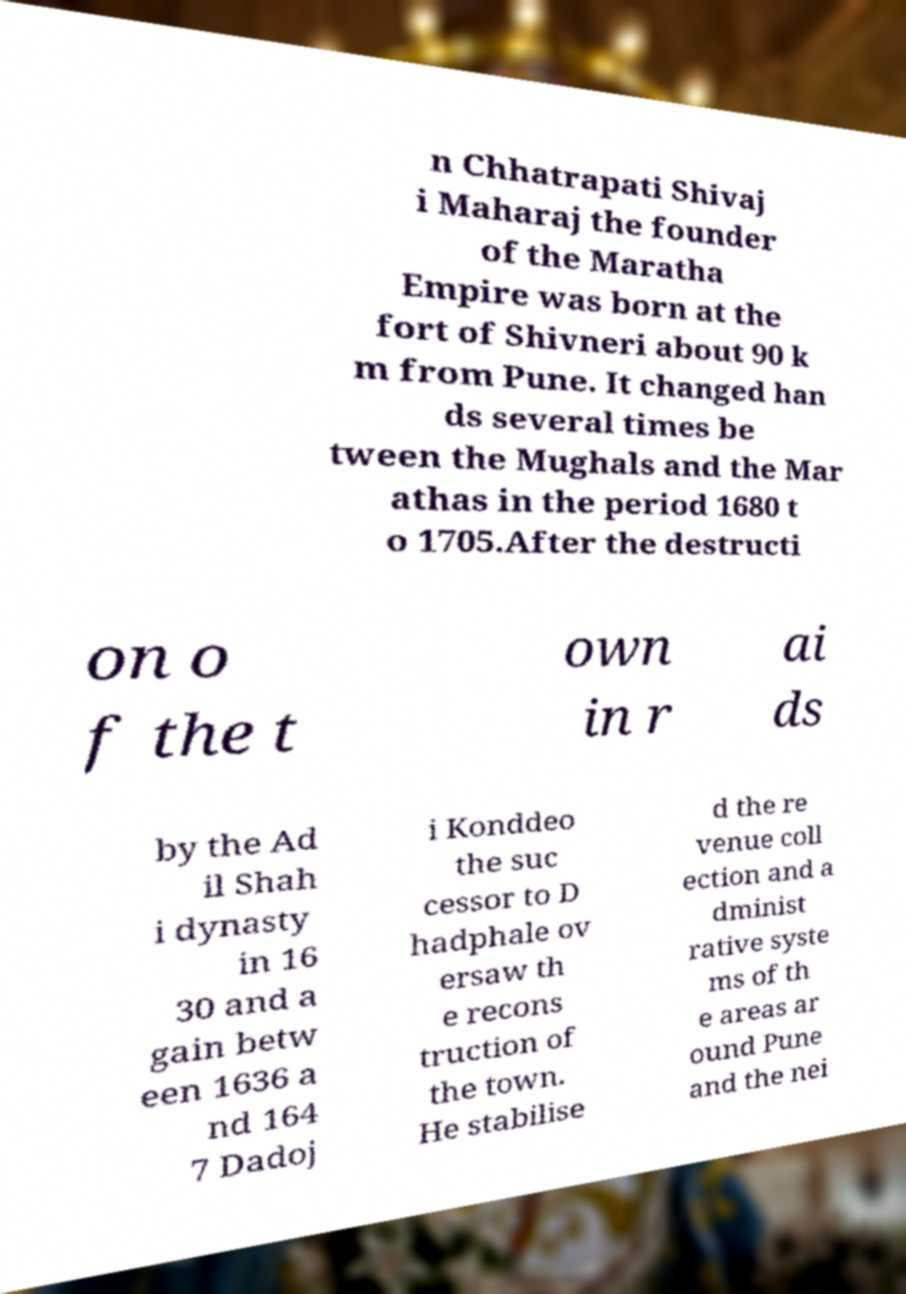Could you extract and type out the text from this image? n Chhatrapati Shivaj i Maharaj the founder of the Maratha Empire was born at the fort of Shivneri about 90 k m from Pune. It changed han ds several times be tween the Mughals and the Mar athas in the period 1680 t o 1705.After the destructi on o f the t own in r ai ds by the Ad il Shah i dynasty in 16 30 and a gain betw een 1636 a nd 164 7 Dadoj i Konddeo the suc cessor to D hadphale ov ersaw th e recons truction of the town. He stabilise d the re venue coll ection and a dminist rative syste ms of th e areas ar ound Pune and the nei 